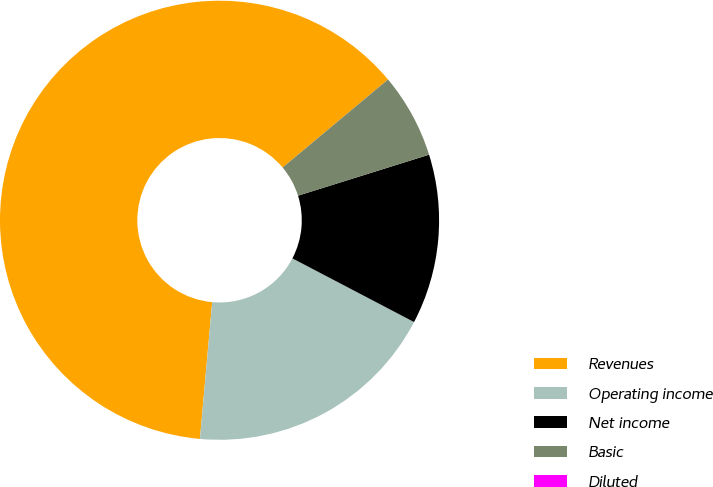<chart> <loc_0><loc_0><loc_500><loc_500><pie_chart><fcel>Revenues<fcel>Operating income<fcel>Net income<fcel>Basic<fcel>Diluted<nl><fcel>62.5%<fcel>18.75%<fcel>12.5%<fcel>6.25%<fcel>0.0%<nl></chart> 